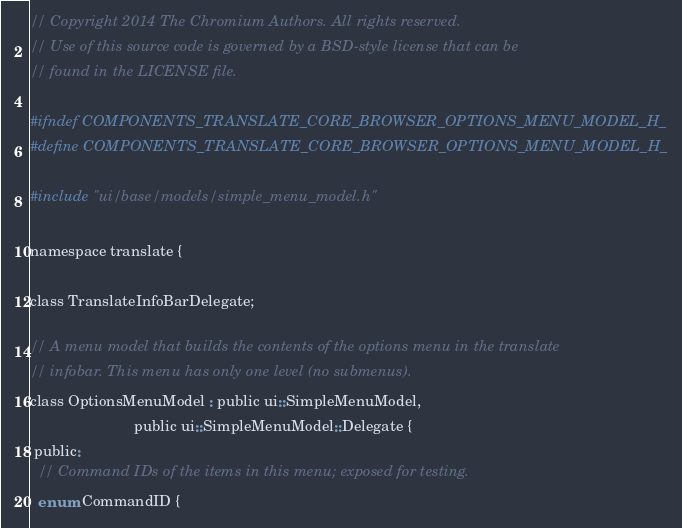Convert code to text. <code><loc_0><loc_0><loc_500><loc_500><_C_>// Copyright 2014 The Chromium Authors. All rights reserved.
// Use of this source code is governed by a BSD-style license that can be
// found in the LICENSE file.

#ifndef COMPONENTS_TRANSLATE_CORE_BROWSER_OPTIONS_MENU_MODEL_H_
#define COMPONENTS_TRANSLATE_CORE_BROWSER_OPTIONS_MENU_MODEL_H_

#include "ui/base/models/simple_menu_model.h"

namespace translate {

class TranslateInfoBarDelegate;

// A menu model that builds the contents of the options menu in the translate
// infobar. This menu has only one level (no submenus).
class OptionsMenuModel : public ui::SimpleMenuModel,
                         public ui::SimpleMenuModel::Delegate {
 public:
  // Command IDs of the items in this menu; exposed for testing.
  enum CommandID {</code> 